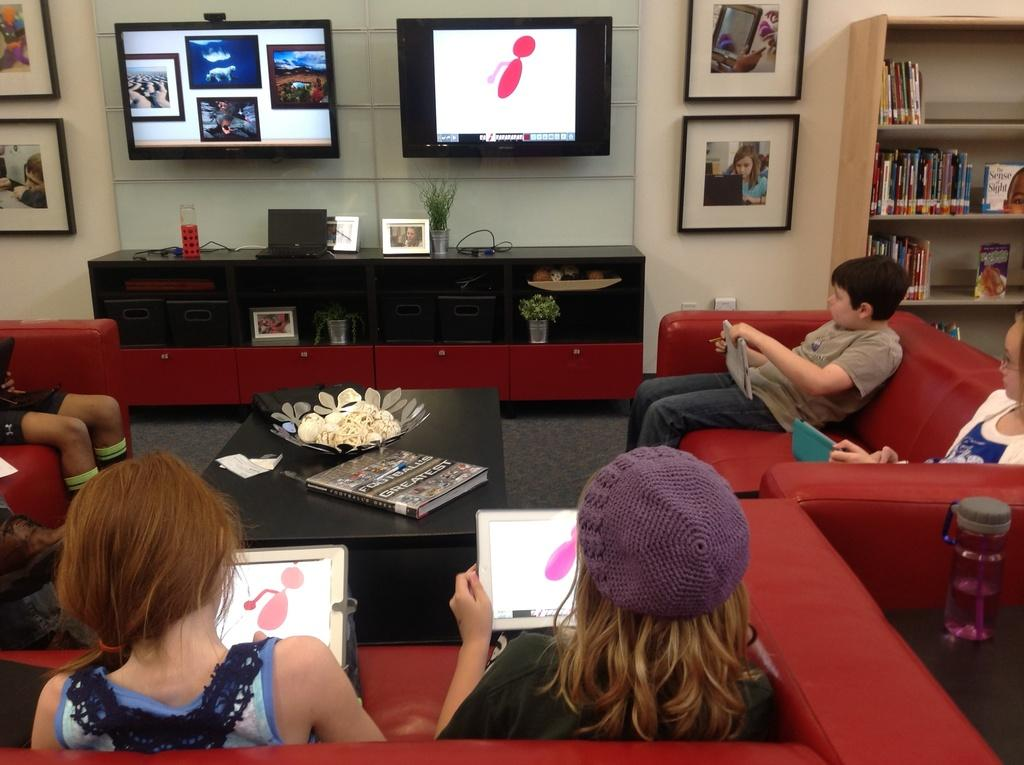Who is participating in the activity shown in the image? Children are involved in the activity. What are the children doing in the image? They are projecting a drawing. How is the drawing being displayed? The drawing is being displayed on a screen. What device is being used to project the drawing? A tablet PC is being used for this purpose. What type of chess pieces can be seen on the table in the image? There are no chess pieces visible in the image; the children are projecting a drawing using a tablet PC. How many children are sitting in a circle around the screen in the image? There is no circle or specific seating arrangement mentioned in the image; the children are simply involved in the activity. 